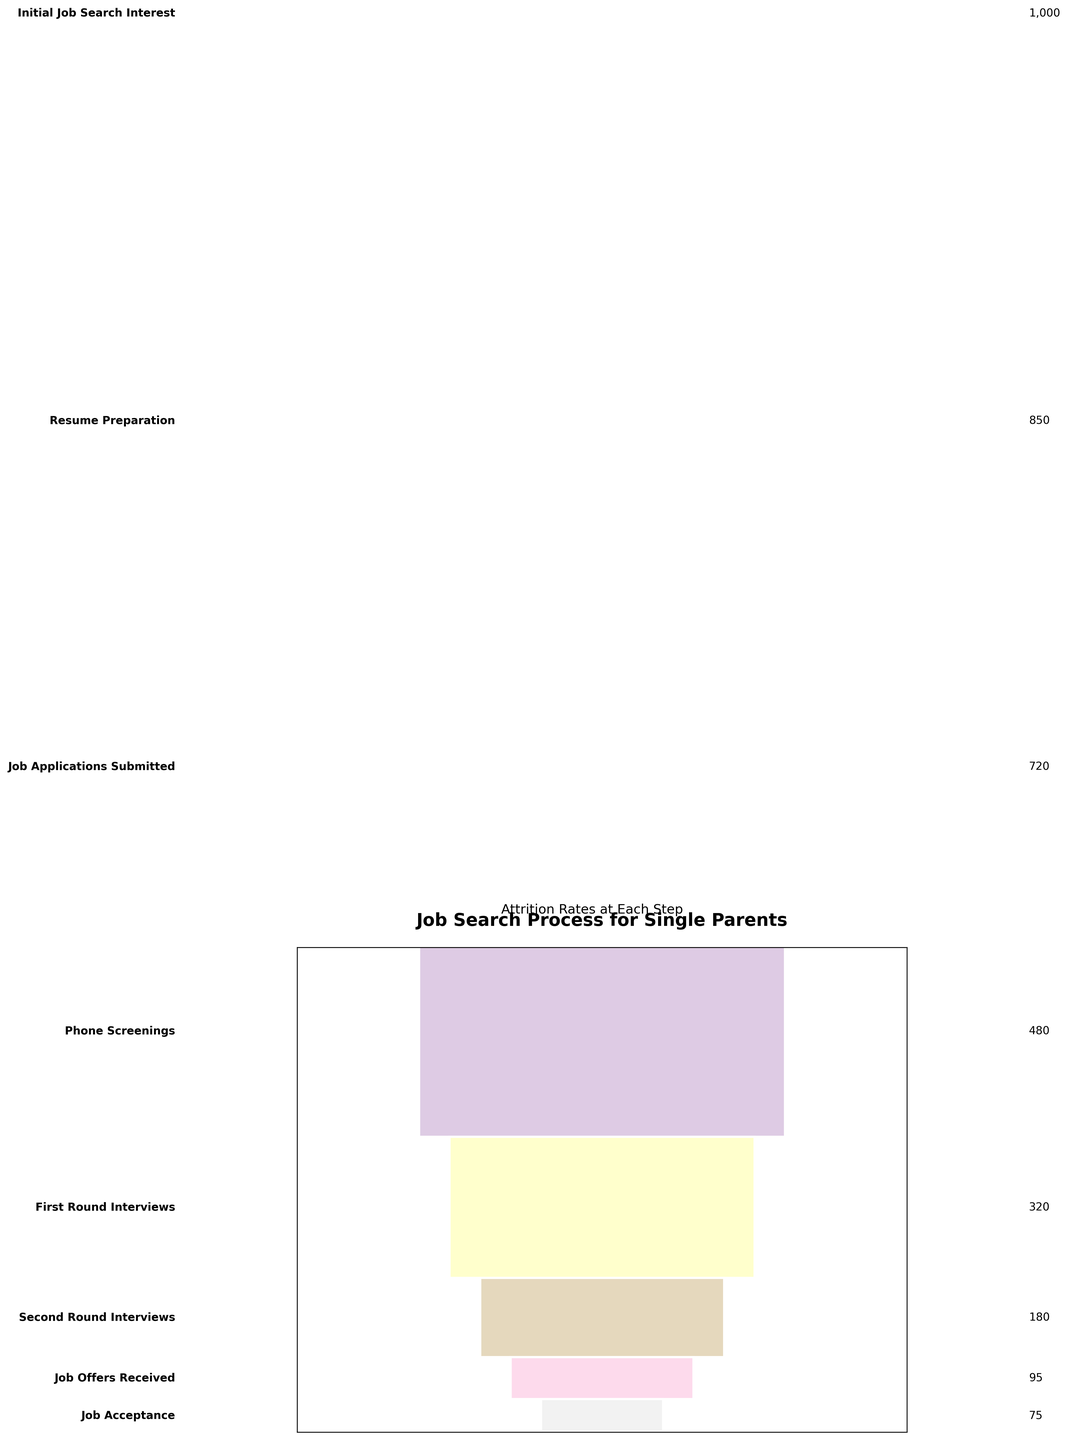What's the title of the Funnel Chart? The title of the Funnel Chart is displayed at the top center of the figure. It can be easily read when looking at the chart.
Answer: Job Search Process for Single Parents How many single parents received job offers? The number of single parents who received job offers is shown next to the step "Job Offers Received" on the left side of the funnel.
Answer: 95 Which step in the job search process saw the largest drop in the number of single parents? By looking at the differences between consecutive steps, identify the largest drop. Subtract each step's number from the previous step and find the highest value. 1000-850=150, 850-720=130, 720-480=240, 480-320=160, 320-180=140, 180-95=85, 95-75=20. The largest drop is from "Job Applications Submitted" to "Phone Screenings".
Answer: Job Applications Submitted to Phone Screenings What percentage of single parents accepted job offers out of those who received them? To calculate this, divide the number of job acceptances by the number of job offers received and multiply by 100 to get the percentage: \( \frac{75}{95} \times 100 = 78.95 \% \).
Answer: 78.95% How many single parents made it to the "Second Round Interviews"? The number of single parents who made it to the "Second Round Interviews" is shown next to the step "Second Round Interviews" on the left side of the funnel.
Answer: 180 Which step has the lowest number of single parents? The step with the lowest number of single parents is "Job Acceptance", as it is the smallest bar at the bottom of the funnel.
Answer: Job Acceptance What is the cumulative drop from "Resume Preparation" to "First Round Interviews"? Sum the drops in each step from "Resume Preparation" to "First Round Interviews": (850 - 720) + (720 - 480) = 130 + 240.
Answer: 370 